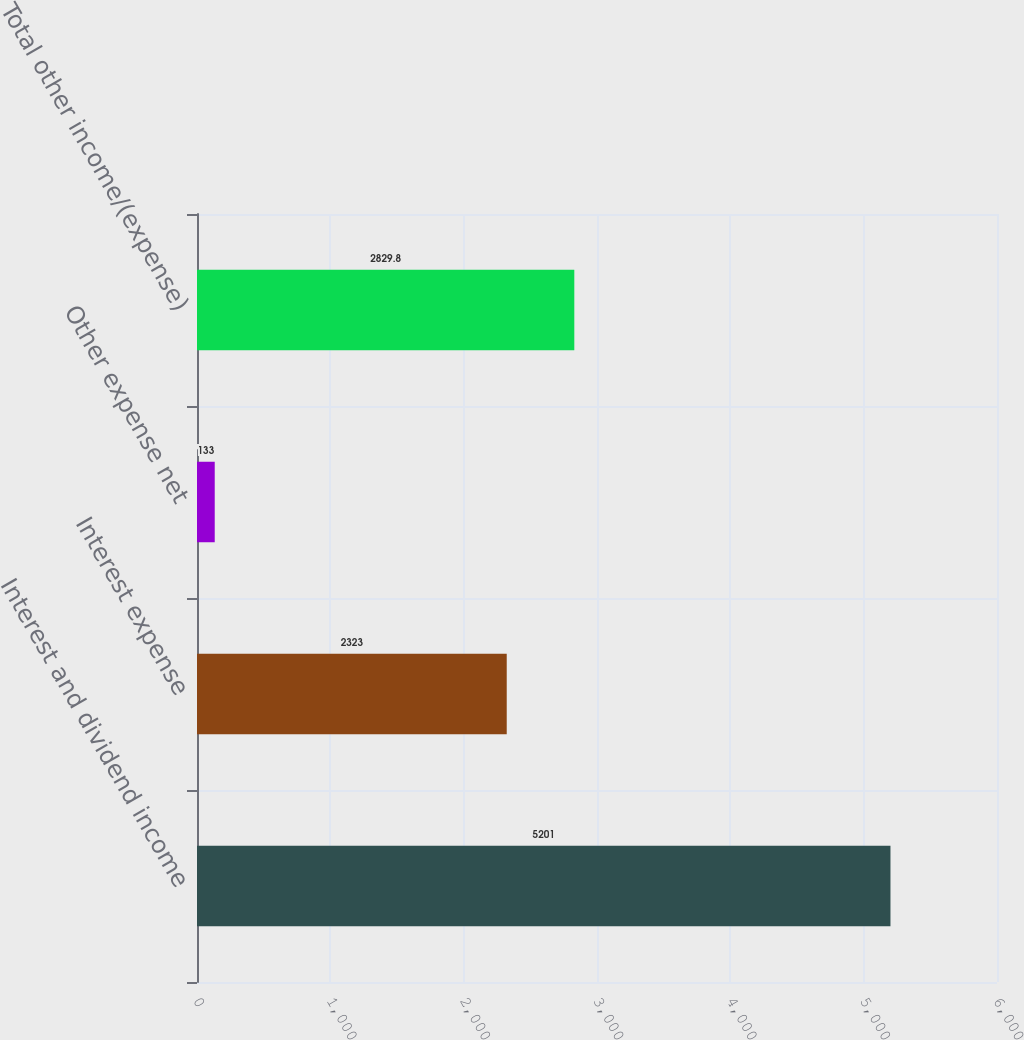Convert chart. <chart><loc_0><loc_0><loc_500><loc_500><bar_chart><fcel>Interest and dividend income<fcel>Interest expense<fcel>Other expense net<fcel>Total other income/(expense)<nl><fcel>5201<fcel>2323<fcel>133<fcel>2829.8<nl></chart> 